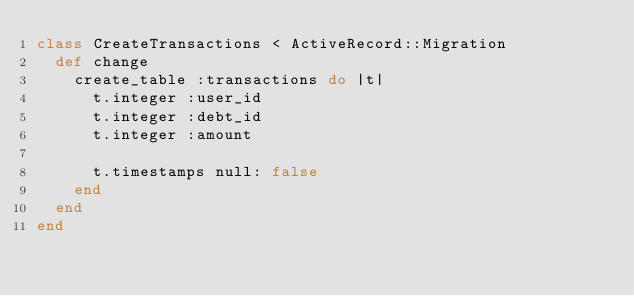<code> <loc_0><loc_0><loc_500><loc_500><_Ruby_>class CreateTransactions < ActiveRecord::Migration
  def change
    create_table :transactions do |t|
      t.integer :user_id
      t.integer :debt_id
      t.integer :amount

      t.timestamps null: false
    end
  end
end
</code> 